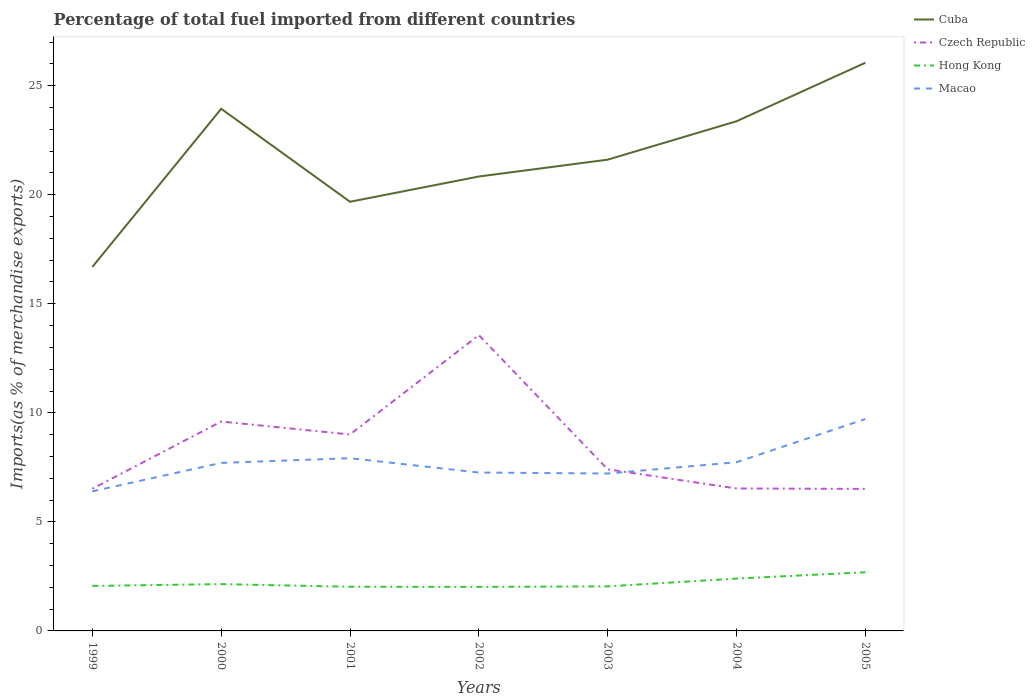Is the number of lines equal to the number of legend labels?
Your answer should be compact. Yes. Across all years, what is the maximum percentage of imports to different countries in Cuba?
Offer a very short reply. 16.69. In which year was the percentage of imports to different countries in Hong Kong maximum?
Your answer should be compact. 2002. What is the total percentage of imports to different countries in Hong Kong in the graph?
Ensure brevity in your answer.  -0.54. What is the difference between the highest and the second highest percentage of imports to different countries in Cuba?
Keep it short and to the point. 9.36. Are the values on the major ticks of Y-axis written in scientific E-notation?
Provide a succinct answer. No. What is the title of the graph?
Your response must be concise. Percentage of total fuel imported from different countries. What is the label or title of the Y-axis?
Provide a succinct answer. Imports(as % of merchandise exports). What is the Imports(as % of merchandise exports) in Cuba in 1999?
Provide a short and direct response. 16.69. What is the Imports(as % of merchandise exports) in Czech Republic in 1999?
Offer a very short reply. 6.52. What is the Imports(as % of merchandise exports) in Hong Kong in 1999?
Your answer should be compact. 2.06. What is the Imports(as % of merchandise exports) in Macao in 1999?
Provide a short and direct response. 6.4. What is the Imports(as % of merchandise exports) in Cuba in 2000?
Provide a short and direct response. 23.94. What is the Imports(as % of merchandise exports) of Czech Republic in 2000?
Provide a short and direct response. 9.6. What is the Imports(as % of merchandise exports) of Hong Kong in 2000?
Keep it short and to the point. 2.15. What is the Imports(as % of merchandise exports) of Macao in 2000?
Ensure brevity in your answer.  7.7. What is the Imports(as % of merchandise exports) of Cuba in 2001?
Offer a very short reply. 19.68. What is the Imports(as % of merchandise exports) in Czech Republic in 2001?
Offer a very short reply. 9.01. What is the Imports(as % of merchandise exports) in Hong Kong in 2001?
Offer a terse response. 2.03. What is the Imports(as % of merchandise exports) in Macao in 2001?
Your response must be concise. 7.92. What is the Imports(as % of merchandise exports) in Cuba in 2002?
Your answer should be compact. 20.84. What is the Imports(as % of merchandise exports) of Czech Republic in 2002?
Keep it short and to the point. 13.56. What is the Imports(as % of merchandise exports) of Hong Kong in 2002?
Give a very brief answer. 2.02. What is the Imports(as % of merchandise exports) in Macao in 2002?
Keep it short and to the point. 7.26. What is the Imports(as % of merchandise exports) in Cuba in 2003?
Provide a short and direct response. 21.61. What is the Imports(as % of merchandise exports) of Czech Republic in 2003?
Provide a succinct answer. 7.41. What is the Imports(as % of merchandise exports) in Hong Kong in 2003?
Your answer should be very brief. 2.04. What is the Imports(as % of merchandise exports) in Macao in 2003?
Your answer should be very brief. 7.22. What is the Imports(as % of merchandise exports) of Cuba in 2004?
Your answer should be very brief. 23.37. What is the Imports(as % of merchandise exports) of Czech Republic in 2004?
Ensure brevity in your answer.  6.53. What is the Imports(as % of merchandise exports) of Hong Kong in 2004?
Offer a very short reply. 2.4. What is the Imports(as % of merchandise exports) of Macao in 2004?
Ensure brevity in your answer.  7.74. What is the Imports(as % of merchandise exports) of Cuba in 2005?
Provide a short and direct response. 26.05. What is the Imports(as % of merchandise exports) of Czech Republic in 2005?
Provide a succinct answer. 6.51. What is the Imports(as % of merchandise exports) of Hong Kong in 2005?
Provide a short and direct response. 2.69. What is the Imports(as % of merchandise exports) in Macao in 2005?
Your response must be concise. 9.72. Across all years, what is the maximum Imports(as % of merchandise exports) of Cuba?
Your response must be concise. 26.05. Across all years, what is the maximum Imports(as % of merchandise exports) of Czech Republic?
Offer a very short reply. 13.56. Across all years, what is the maximum Imports(as % of merchandise exports) in Hong Kong?
Keep it short and to the point. 2.69. Across all years, what is the maximum Imports(as % of merchandise exports) in Macao?
Your response must be concise. 9.72. Across all years, what is the minimum Imports(as % of merchandise exports) in Cuba?
Your answer should be very brief. 16.69. Across all years, what is the minimum Imports(as % of merchandise exports) of Czech Republic?
Offer a terse response. 6.51. Across all years, what is the minimum Imports(as % of merchandise exports) of Hong Kong?
Offer a terse response. 2.02. Across all years, what is the minimum Imports(as % of merchandise exports) in Macao?
Ensure brevity in your answer.  6.4. What is the total Imports(as % of merchandise exports) of Cuba in the graph?
Ensure brevity in your answer.  152.17. What is the total Imports(as % of merchandise exports) of Czech Republic in the graph?
Your response must be concise. 59.14. What is the total Imports(as % of merchandise exports) in Hong Kong in the graph?
Your answer should be compact. 15.39. What is the total Imports(as % of merchandise exports) in Macao in the graph?
Your response must be concise. 53.96. What is the difference between the Imports(as % of merchandise exports) in Cuba in 1999 and that in 2000?
Your response must be concise. -7.25. What is the difference between the Imports(as % of merchandise exports) of Czech Republic in 1999 and that in 2000?
Ensure brevity in your answer.  -3.08. What is the difference between the Imports(as % of merchandise exports) of Hong Kong in 1999 and that in 2000?
Ensure brevity in your answer.  -0.08. What is the difference between the Imports(as % of merchandise exports) of Macao in 1999 and that in 2000?
Offer a terse response. -1.3. What is the difference between the Imports(as % of merchandise exports) in Cuba in 1999 and that in 2001?
Keep it short and to the point. -2.99. What is the difference between the Imports(as % of merchandise exports) in Czech Republic in 1999 and that in 2001?
Offer a very short reply. -2.49. What is the difference between the Imports(as % of merchandise exports) of Hong Kong in 1999 and that in 2001?
Offer a very short reply. 0.04. What is the difference between the Imports(as % of merchandise exports) in Macao in 1999 and that in 2001?
Make the answer very short. -1.52. What is the difference between the Imports(as % of merchandise exports) in Cuba in 1999 and that in 2002?
Give a very brief answer. -4.15. What is the difference between the Imports(as % of merchandise exports) in Czech Republic in 1999 and that in 2002?
Provide a short and direct response. -7.04. What is the difference between the Imports(as % of merchandise exports) of Hong Kong in 1999 and that in 2002?
Keep it short and to the point. 0.05. What is the difference between the Imports(as % of merchandise exports) in Macao in 1999 and that in 2002?
Offer a terse response. -0.86. What is the difference between the Imports(as % of merchandise exports) of Cuba in 1999 and that in 2003?
Offer a terse response. -4.92. What is the difference between the Imports(as % of merchandise exports) of Czech Republic in 1999 and that in 2003?
Keep it short and to the point. -0.89. What is the difference between the Imports(as % of merchandise exports) of Hong Kong in 1999 and that in 2003?
Offer a terse response. 0.02. What is the difference between the Imports(as % of merchandise exports) in Macao in 1999 and that in 2003?
Give a very brief answer. -0.82. What is the difference between the Imports(as % of merchandise exports) in Cuba in 1999 and that in 2004?
Ensure brevity in your answer.  -6.68. What is the difference between the Imports(as % of merchandise exports) in Czech Republic in 1999 and that in 2004?
Make the answer very short. -0.01. What is the difference between the Imports(as % of merchandise exports) of Hong Kong in 1999 and that in 2004?
Your response must be concise. -0.34. What is the difference between the Imports(as % of merchandise exports) of Macao in 1999 and that in 2004?
Offer a very short reply. -1.33. What is the difference between the Imports(as % of merchandise exports) in Cuba in 1999 and that in 2005?
Your answer should be very brief. -9.36. What is the difference between the Imports(as % of merchandise exports) in Czech Republic in 1999 and that in 2005?
Give a very brief answer. 0.01. What is the difference between the Imports(as % of merchandise exports) of Hong Kong in 1999 and that in 2005?
Make the answer very short. -0.63. What is the difference between the Imports(as % of merchandise exports) in Macao in 1999 and that in 2005?
Your response must be concise. -3.31. What is the difference between the Imports(as % of merchandise exports) of Cuba in 2000 and that in 2001?
Make the answer very short. 4.26. What is the difference between the Imports(as % of merchandise exports) in Czech Republic in 2000 and that in 2001?
Ensure brevity in your answer.  0.59. What is the difference between the Imports(as % of merchandise exports) of Hong Kong in 2000 and that in 2001?
Keep it short and to the point. 0.12. What is the difference between the Imports(as % of merchandise exports) of Macao in 2000 and that in 2001?
Your answer should be compact. -0.22. What is the difference between the Imports(as % of merchandise exports) in Cuba in 2000 and that in 2002?
Offer a very short reply. 3.11. What is the difference between the Imports(as % of merchandise exports) in Czech Republic in 2000 and that in 2002?
Offer a very short reply. -3.96. What is the difference between the Imports(as % of merchandise exports) of Hong Kong in 2000 and that in 2002?
Keep it short and to the point. 0.13. What is the difference between the Imports(as % of merchandise exports) in Macao in 2000 and that in 2002?
Give a very brief answer. 0.44. What is the difference between the Imports(as % of merchandise exports) of Cuba in 2000 and that in 2003?
Your answer should be very brief. 2.33. What is the difference between the Imports(as % of merchandise exports) of Czech Republic in 2000 and that in 2003?
Provide a succinct answer. 2.19. What is the difference between the Imports(as % of merchandise exports) of Hong Kong in 2000 and that in 2003?
Ensure brevity in your answer.  0.1. What is the difference between the Imports(as % of merchandise exports) of Macao in 2000 and that in 2003?
Your answer should be compact. 0.49. What is the difference between the Imports(as % of merchandise exports) in Cuba in 2000 and that in 2004?
Offer a terse response. 0.57. What is the difference between the Imports(as % of merchandise exports) in Czech Republic in 2000 and that in 2004?
Give a very brief answer. 3.07. What is the difference between the Imports(as % of merchandise exports) of Hong Kong in 2000 and that in 2004?
Keep it short and to the point. -0.25. What is the difference between the Imports(as % of merchandise exports) in Macao in 2000 and that in 2004?
Offer a terse response. -0.03. What is the difference between the Imports(as % of merchandise exports) of Cuba in 2000 and that in 2005?
Ensure brevity in your answer.  -2.11. What is the difference between the Imports(as % of merchandise exports) of Czech Republic in 2000 and that in 2005?
Offer a terse response. 3.09. What is the difference between the Imports(as % of merchandise exports) in Hong Kong in 2000 and that in 2005?
Offer a terse response. -0.54. What is the difference between the Imports(as % of merchandise exports) in Macao in 2000 and that in 2005?
Offer a very short reply. -2.01. What is the difference between the Imports(as % of merchandise exports) in Cuba in 2001 and that in 2002?
Your answer should be very brief. -1.16. What is the difference between the Imports(as % of merchandise exports) in Czech Republic in 2001 and that in 2002?
Keep it short and to the point. -4.56. What is the difference between the Imports(as % of merchandise exports) in Hong Kong in 2001 and that in 2002?
Provide a succinct answer. 0.01. What is the difference between the Imports(as % of merchandise exports) of Macao in 2001 and that in 2002?
Provide a succinct answer. 0.66. What is the difference between the Imports(as % of merchandise exports) of Cuba in 2001 and that in 2003?
Your answer should be very brief. -1.93. What is the difference between the Imports(as % of merchandise exports) of Czech Republic in 2001 and that in 2003?
Give a very brief answer. 1.6. What is the difference between the Imports(as % of merchandise exports) of Hong Kong in 2001 and that in 2003?
Your response must be concise. -0.02. What is the difference between the Imports(as % of merchandise exports) in Macao in 2001 and that in 2003?
Your answer should be compact. 0.7. What is the difference between the Imports(as % of merchandise exports) in Cuba in 2001 and that in 2004?
Your answer should be compact. -3.69. What is the difference between the Imports(as % of merchandise exports) in Czech Republic in 2001 and that in 2004?
Offer a terse response. 2.48. What is the difference between the Imports(as % of merchandise exports) of Hong Kong in 2001 and that in 2004?
Provide a succinct answer. -0.37. What is the difference between the Imports(as % of merchandise exports) of Macao in 2001 and that in 2004?
Your response must be concise. 0.18. What is the difference between the Imports(as % of merchandise exports) in Cuba in 2001 and that in 2005?
Keep it short and to the point. -6.37. What is the difference between the Imports(as % of merchandise exports) in Czech Republic in 2001 and that in 2005?
Provide a short and direct response. 2.5. What is the difference between the Imports(as % of merchandise exports) of Hong Kong in 2001 and that in 2005?
Provide a short and direct response. -0.67. What is the difference between the Imports(as % of merchandise exports) of Macao in 2001 and that in 2005?
Keep it short and to the point. -1.79. What is the difference between the Imports(as % of merchandise exports) of Cuba in 2002 and that in 2003?
Keep it short and to the point. -0.77. What is the difference between the Imports(as % of merchandise exports) of Czech Republic in 2002 and that in 2003?
Keep it short and to the point. 6.15. What is the difference between the Imports(as % of merchandise exports) of Hong Kong in 2002 and that in 2003?
Ensure brevity in your answer.  -0.03. What is the difference between the Imports(as % of merchandise exports) of Macao in 2002 and that in 2003?
Your response must be concise. 0.05. What is the difference between the Imports(as % of merchandise exports) of Cuba in 2002 and that in 2004?
Keep it short and to the point. -2.53. What is the difference between the Imports(as % of merchandise exports) of Czech Republic in 2002 and that in 2004?
Keep it short and to the point. 7.03. What is the difference between the Imports(as % of merchandise exports) in Hong Kong in 2002 and that in 2004?
Your answer should be very brief. -0.38. What is the difference between the Imports(as % of merchandise exports) in Macao in 2002 and that in 2004?
Offer a very short reply. -0.47. What is the difference between the Imports(as % of merchandise exports) in Cuba in 2002 and that in 2005?
Your answer should be very brief. -5.21. What is the difference between the Imports(as % of merchandise exports) in Czech Republic in 2002 and that in 2005?
Offer a terse response. 7.05. What is the difference between the Imports(as % of merchandise exports) in Hong Kong in 2002 and that in 2005?
Make the answer very short. -0.67. What is the difference between the Imports(as % of merchandise exports) in Macao in 2002 and that in 2005?
Your answer should be compact. -2.45. What is the difference between the Imports(as % of merchandise exports) of Cuba in 2003 and that in 2004?
Your response must be concise. -1.76. What is the difference between the Imports(as % of merchandise exports) in Czech Republic in 2003 and that in 2004?
Your response must be concise. 0.88. What is the difference between the Imports(as % of merchandise exports) in Hong Kong in 2003 and that in 2004?
Provide a short and direct response. -0.36. What is the difference between the Imports(as % of merchandise exports) of Macao in 2003 and that in 2004?
Your answer should be compact. -0.52. What is the difference between the Imports(as % of merchandise exports) in Cuba in 2003 and that in 2005?
Give a very brief answer. -4.44. What is the difference between the Imports(as % of merchandise exports) of Czech Republic in 2003 and that in 2005?
Provide a short and direct response. 0.9. What is the difference between the Imports(as % of merchandise exports) of Hong Kong in 2003 and that in 2005?
Your answer should be compact. -0.65. What is the difference between the Imports(as % of merchandise exports) in Macao in 2003 and that in 2005?
Your response must be concise. -2.5. What is the difference between the Imports(as % of merchandise exports) in Cuba in 2004 and that in 2005?
Ensure brevity in your answer.  -2.68. What is the difference between the Imports(as % of merchandise exports) in Czech Republic in 2004 and that in 2005?
Make the answer very short. 0.02. What is the difference between the Imports(as % of merchandise exports) in Hong Kong in 2004 and that in 2005?
Offer a very short reply. -0.29. What is the difference between the Imports(as % of merchandise exports) of Macao in 2004 and that in 2005?
Provide a short and direct response. -1.98. What is the difference between the Imports(as % of merchandise exports) of Cuba in 1999 and the Imports(as % of merchandise exports) of Czech Republic in 2000?
Your answer should be very brief. 7.09. What is the difference between the Imports(as % of merchandise exports) of Cuba in 1999 and the Imports(as % of merchandise exports) of Hong Kong in 2000?
Your answer should be compact. 14.54. What is the difference between the Imports(as % of merchandise exports) of Cuba in 1999 and the Imports(as % of merchandise exports) of Macao in 2000?
Ensure brevity in your answer.  8.99. What is the difference between the Imports(as % of merchandise exports) in Czech Republic in 1999 and the Imports(as % of merchandise exports) in Hong Kong in 2000?
Provide a short and direct response. 4.37. What is the difference between the Imports(as % of merchandise exports) of Czech Republic in 1999 and the Imports(as % of merchandise exports) of Macao in 2000?
Offer a terse response. -1.18. What is the difference between the Imports(as % of merchandise exports) in Hong Kong in 1999 and the Imports(as % of merchandise exports) in Macao in 2000?
Keep it short and to the point. -5.64. What is the difference between the Imports(as % of merchandise exports) of Cuba in 1999 and the Imports(as % of merchandise exports) of Czech Republic in 2001?
Provide a succinct answer. 7.68. What is the difference between the Imports(as % of merchandise exports) of Cuba in 1999 and the Imports(as % of merchandise exports) of Hong Kong in 2001?
Ensure brevity in your answer.  14.66. What is the difference between the Imports(as % of merchandise exports) of Cuba in 1999 and the Imports(as % of merchandise exports) of Macao in 2001?
Make the answer very short. 8.77. What is the difference between the Imports(as % of merchandise exports) in Czech Republic in 1999 and the Imports(as % of merchandise exports) in Hong Kong in 2001?
Keep it short and to the point. 4.49. What is the difference between the Imports(as % of merchandise exports) in Czech Republic in 1999 and the Imports(as % of merchandise exports) in Macao in 2001?
Offer a very short reply. -1.4. What is the difference between the Imports(as % of merchandise exports) in Hong Kong in 1999 and the Imports(as % of merchandise exports) in Macao in 2001?
Keep it short and to the point. -5.86. What is the difference between the Imports(as % of merchandise exports) in Cuba in 1999 and the Imports(as % of merchandise exports) in Czech Republic in 2002?
Offer a terse response. 3.13. What is the difference between the Imports(as % of merchandise exports) of Cuba in 1999 and the Imports(as % of merchandise exports) of Hong Kong in 2002?
Make the answer very short. 14.67. What is the difference between the Imports(as % of merchandise exports) of Cuba in 1999 and the Imports(as % of merchandise exports) of Macao in 2002?
Provide a succinct answer. 9.43. What is the difference between the Imports(as % of merchandise exports) of Czech Republic in 1999 and the Imports(as % of merchandise exports) of Hong Kong in 2002?
Keep it short and to the point. 4.5. What is the difference between the Imports(as % of merchandise exports) in Czech Republic in 1999 and the Imports(as % of merchandise exports) in Macao in 2002?
Your answer should be compact. -0.74. What is the difference between the Imports(as % of merchandise exports) of Hong Kong in 1999 and the Imports(as % of merchandise exports) of Macao in 2002?
Keep it short and to the point. -5.2. What is the difference between the Imports(as % of merchandise exports) of Cuba in 1999 and the Imports(as % of merchandise exports) of Czech Republic in 2003?
Your answer should be compact. 9.28. What is the difference between the Imports(as % of merchandise exports) of Cuba in 1999 and the Imports(as % of merchandise exports) of Hong Kong in 2003?
Make the answer very short. 14.65. What is the difference between the Imports(as % of merchandise exports) in Cuba in 1999 and the Imports(as % of merchandise exports) in Macao in 2003?
Keep it short and to the point. 9.47. What is the difference between the Imports(as % of merchandise exports) of Czech Republic in 1999 and the Imports(as % of merchandise exports) of Hong Kong in 2003?
Offer a terse response. 4.48. What is the difference between the Imports(as % of merchandise exports) in Czech Republic in 1999 and the Imports(as % of merchandise exports) in Macao in 2003?
Keep it short and to the point. -0.7. What is the difference between the Imports(as % of merchandise exports) of Hong Kong in 1999 and the Imports(as % of merchandise exports) of Macao in 2003?
Provide a short and direct response. -5.15. What is the difference between the Imports(as % of merchandise exports) of Cuba in 1999 and the Imports(as % of merchandise exports) of Czech Republic in 2004?
Your response must be concise. 10.16. What is the difference between the Imports(as % of merchandise exports) in Cuba in 1999 and the Imports(as % of merchandise exports) in Hong Kong in 2004?
Your response must be concise. 14.29. What is the difference between the Imports(as % of merchandise exports) of Cuba in 1999 and the Imports(as % of merchandise exports) of Macao in 2004?
Your answer should be compact. 8.95. What is the difference between the Imports(as % of merchandise exports) in Czech Republic in 1999 and the Imports(as % of merchandise exports) in Hong Kong in 2004?
Your response must be concise. 4.12. What is the difference between the Imports(as % of merchandise exports) of Czech Republic in 1999 and the Imports(as % of merchandise exports) of Macao in 2004?
Ensure brevity in your answer.  -1.22. What is the difference between the Imports(as % of merchandise exports) of Hong Kong in 1999 and the Imports(as % of merchandise exports) of Macao in 2004?
Make the answer very short. -5.67. What is the difference between the Imports(as % of merchandise exports) of Cuba in 1999 and the Imports(as % of merchandise exports) of Czech Republic in 2005?
Offer a very short reply. 10.18. What is the difference between the Imports(as % of merchandise exports) in Cuba in 1999 and the Imports(as % of merchandise exports) in Hong Kong in 2005?
Offer a very short reply. 14. What is the difference between the Imports(as % of merchandise exports) in Cuba in 1999 and the Imports(as % of merchandise exports) in Macao in 2005?
Offer a very short reply. 6.97. What is the difference between the Imports(as % of merchandise exports) of Czech Republic in 1999 and the Imports(as % of merchandise exports) of Hong Kong in 2005?
Your answer should be very brief. 3.83. What is the difference between the Imports(as % of merchandise exports) of Czech Republic in 1999 and the Imports(as % of merchandise exports) of Macao in 2005?
Ensure brevity in your answer.  -3.2. What is the difference between the Imports(as % of merchandise exports) of Hong Kong in 1999 and the Imports(as % of merchandise exports) of Macao in 2005?
Provide a succinct answer. -7.65. What is the difference between the Imports(as % of merchandise exports) of Cuba in 2000 and the Imports(as % of merchandise exports) of Czech Republic in 2001?
Give a very brief answer. 14.94. What is the difference between the Imports(as % of merchandise exports) of Cuba in 2000 and the Imports(as % of merchandise exports) of Hong Kong in 2001?
Your answer should be compact. 21.92. What is the difference between the Imports(as % of merchandise exports) in Cuba in 2000 and the Imports(as % of merchandise exports) in Macao in 2001?
Provide a short and direct response. 16.02. What is the difference between the Imports(as % of merchandise exports) in Czech Republic in 2000 and the Imports(as % of merchandise exports) in Hong Kong in 2001?
Ensure brevity in your answer.  7.58. What is the difference between the Imports(as % of merchandise exports) in Czech Republic in 2000 and the Imports(as % of merchandise exports) in Macao in 2001?
Provide a succinct answer. 1.68. What is the difference between the Imports(as % of merchandise exports) in Hong Kong in 2000 and the Imports(as % of merchandise exports) in Macao in 2001?
Your answer should be compact. -5.77. What is the difference between the Imports(as % of merchandise exports) of Cuba in 2000 and the Imports(as % of merchandise exports) of Czech Republic in 2002?
Provide a short and direct response. 10.38. What is the difference between the Imports(as % of merchandise exports) of Cuba in 2000 and the Imports(as % of merchandise exports) of Hong Kong in 2002?
Offer a terse response. 21.92. What is the difference between the Imports(as % of merchandise exports) of Cuba in 2000 and the Imports(as % of merchandise exports) of Macao in 2002?
Keep it short and to the point. 16.68. What is the difference between the Imports(as % of merchandise exports) of Czech Republic in 2000 and the Imports(as % of merchandise exports) of Hong Kong in 2002?
Keep it short and to the point. 7.58. What is the difference between the Imports(as % of merchandise exports) of Czech Republic in 2000 and the Imports(as % of merchandise exports) of Macao in 2002?
Give a very brief answer. 2.34. What is the difference between the Imports(as % of merchandise exports) of Hong Kong in 2000 and the Imports(as % of merchandise exports) of Macao in 2002?
Give a very brief answer. -5.12. What is the difference between the Imports(as % of merchandise exports) in Cuba in 2000 and the Imports(as % of merchandise exports) in Czech Republic in 2003?
Your response must be concise. 16.53. What is the difference between the Imports(as % of merchandise exports) in Cuba in 2000 and the Imports(as % of merchandise exports) in Hong Kong in 2003?
Your answer should be very brief. 21.9. What is the difference between the Imports(as % of merchandise exports) in Cuba in 2000 and the Imports(as % of merchandise exports) in Macao in 2003?
Offer a terse response. 16.73. What is the difference between the Imports(as % of merchandise exports) in Czech Republic in 2000 and the Imports(as % of merchandise exports) in Hong Kong in 2003?
Give a very brief answer. 7.56. What is the difference between the Imports(as % of merchandise exports) of Czech Republic in 2000 and the Imports(as % of merchandise exports) of Macao in 2003?
Your answer should be compact. 2.38. What is the difference between the Imports(as % of merchandise exports) of Hong Kong in 2000 and the Imports(as % of merchandise exports) of Macao in 2003?
Your response must be concise. -5.07. What is the difference between the Imports(as % of merchandise exports) in Cuba in 2000 and the Imports(as % of merchandise exports) in Czech Republic in 2004?
Make the answer very short. 17.41. What is the difference between the Imports(as % of merchandise exports) in Cuba in 2000 and the Imports(as % of merchandise exports) in Hong Kong in 2004?
Offer a very short reply. 21.54. What is the difference between the Imports(as % of merchandise exports) in Cuba in 2000 and the Imports(as % of merchandise exports) in Macao in 2004?
Make the answer very short. 16.21. What is the difference between the Imports(as % of merchandise exports) in Czech Republic in 2000 and the Imports(as % of merchandise exports) in Hong Kong in 2004?
Ensure brevity in your answer.  7.2. What is the difference between the Imports(as % of merchandise exports) of Czech Republic in 2000 and the Imports(as % of merchandise exports) of Macao in 2004?
Offer a very short reply. 1.87. What is the difference between the Imports(as % of merchandise exports) of Hong Kong in 2000 and the Imports(as % of merchandise exports) of Macao in 2004?
Ensure brevity in your answer.  -5.59. What is the difference between the Imports(as % of merchandise exports) of Cuba in 2000 and the Imports(as % of merchandise exports) of Czech Republic in 2005?
Offer a terse response. 17.43. What is the difference between the Imports(as % of merchandise exports) in Cuba in 2000 and the Imports(as % of merchandise exports) in Hong Kong in 2005?
Offer a terse response. 21.25. What is the difference between the Imports(as % of merchandise exports) of Cuba in 2000 and the Imports(as % of merchandise exports) of Macao in 2005?
Offer a terse response. 14.23. What is the difference between the Imports(as % of merchandise exports) of Czech Republic in 2000 and the Imports(as % of merchandise exports) of Hong Kong in 2005?
Keep it short and to the point. 6.91. What is the difference between the Imports(as % of merchandise exports) of Czech Republic in 2000 and the Imports(as % of merchandise exports) of Macao in 2005?
Provide a succinct answer. -0.11. What is the difference between the Imports(as % of merchandise exports) of Hong Kong in 2000 and the Imports(as % of merchandise exports) of Macao in 2005?
Provide a short and direct response. -7.57. What is the difference between the Imports(as % of merchandise exports) in Cuba in 2001 and the Imports(as % of merchandise exports) in Czech Republic in 2002?
Make the answer very short. 6.12. What is the difference between the Imports(as % of merchandise exports) in Cuba in 2001 and the Imports(as % of merchandise exports) in Hong Kong in 2002?
Offer a terse response. 17.66. What is the difference between the Imports(as % of merchandise exports) of Cuba in 2001 and the Imports(as % of merchandise exports) of Macao in 2002?
Give a very brief answer. 12.41. What is the difference between the Imports(as % of merchandise exports) in Czech Republic in 2001 and the Imports(as % of merchandise exports) in Hong Kong in 2002?
Your response must be concise. 6.99. What is the difference between the Imports(as % of merchandise exports) in Czech Republic in 2001 and the Imports(as % of merchandise exports) in Macao in 2002?
Offer a terse response. 1.74. What is the difference between the Imports(as % of merchandise exports) in Hong Kong in 2001 and the Imports(as % of merchandise exports) in Macao in 2002?
Provide a short and direct response. -5.24. What is the difference between the Imports(as % of merchandise exports) in Cuba in 2001 and the Imports(as % of merchandise exports) in Czech Republic in 2003?
Your answer should be compact. 12.27. What is the difference between the Imports(as % of merchandise exports) of Cuba in 2001 and the Imports(as % of merchandise exports) of Hong Kong in 2003?
Your response must be concise. 17.63. What is the difference between the Imports(as % of merchandise exports) of Cuba in 2001 and the Imports(as % of merchandise exports) of Macao in 2003?
Offer a very short reply. 12.46. What is the difference between the Imports(as % of merchandise exports) in Czech Republic in 2001 and the Imports(as % of merchandise exports) in Hong Kong in 2003?
Your answer should be very brief. 6.96. What is the difference between the Imports(as % of merchandise exports) in Czech Republic in 2001 and the Imports(as % of merchandise exports) in Macao in 2003?
Keep it short and to the point. 1.79. What is the difference between the Imports(as % of merchandise exports) of Hong Kong in 2001 and the Imports(as % of merchandise exports) of Macao in 2003?
Offer a very short reply. -5.19. What is the difference between the Imports(as % of merchandise exports) in Cuba in 2001 and the Imports(as % of merchandise exports) in Czech Republic in 2004?
Your answer should be very brief. 13.15. What is the difference between the Imports(as % of merchandise exports) in Cuba in 2001 and the Imports(as % of merchandise exports) in Hong Kong in 2004?
Your answer should be compact. 17.28. What is the difference between the Imports(as % of merchandise exports) of Cuba in 2001 and the Imports(as % of merchandise exports) of Macao in 2004?
Make the answer very short. 11.94. What is the difference between the Imports(as % of merchandise exports) in Czech Republic in 2001 and the Imports(as % of merchandise exports) in Hong Kong in 2004?
Your answer should be compact. 6.61. What is the difference between the Imports(as % of merchandise exports) of Czech Republic in 2001 and the Imports(as % of merchandise exports) of Macao in 2004?
Provide a short and direct response. 1.27. What is the difference between the Imports(as % of merchandise exports) in Hong Kong in 2001 and the Imports(as % of merchandise exports) in Macao in 2004?
Your response must be concise. -5.71. What is the difference between the Imports(as % of merchandise exports) of Cuba in 2001 and the Imports(as % of merchandise exports) of Czech Republic in 2005?
Your response must be concise. 13.17. What is the difference between the Imports(as % of merchandise exports) in Cuba in 2001 and the Imports(as % of merchandise exports) in Hong Kong in 2005?
Make the answer very short. 16.99. What is the difference between the Imports(as % of merchandise exports) of Cuba in 2001 and the Imports(as % of merchandise exports) of Macao in 2005?
Keep it short and to the point. 9.96. What is the difference between the Imports(as % of merchandise exports) of Czech Republic in 2001 and the Imports(as % of merchandise exports) of Hong Kong in 2005?
Make the answer very short. 6.32. What is the difference between the Imports(as % of merchandise exports) of Czech Republic in 2001 and the Imports(as % of merchandise exports) of Macao in 2005?
Keep it short and to the point. -0.71. What is the difference between the Imports(as % of merchandise exports) of Hong Kong in 2001 and the Imports(as % of merchandise exports) of Macao in 2005?
Keep it short and to the point. -7.69. What is the difference between the Imports(as % of merchandise exports) of Cuba in 2002 and the Imports(as % of merchandise exports) of Czech Republic in 2003?
Ensure brevity in your answer.  13.43. What is the difference between the Imports(as % of merchandise exports) of Cuba in 2002 and the Imports(as % of merchandise exports) of Hong Kong in 2003?
Your answer should be very brief. 18.79. What is the difference between the Imports(as % of merchandise exports) in Cuba in 2002 and the Imports(as % of merchandise exports) in Macao in 2003?
Offer a very short reply. 13.62. What is the difference between the Imports(as % of merchandise exports) of Czech Republic in 2002 and the Imports(as % of merchandise exports) of Hong Kong in 2003?
Provide a succinct answer. 11.52. What is the difference between the Imports(as % of merchandise exports) in Czech Republic in 2002 and the Imports(as % of merchandise exports) in Macao in 2003?
Keep it short and to the point. 6.35. What is the difference between the Imports(as % of merchandise exports) in Hong Kong in 2002 and the Imports(as % of merchandise exports) in Macao in 2003?
Provide a short and direct response. -5.2. What is the difference between the Imports(as % of merchandise exports) in Cuba in 2002 and the Imports(as % of merchandise exports) in Czech Republic in 2004?
Offer a very short reply. 14.3. What is the difference between the Imports(as % of merchandise exports) of Cuba in 2002 and the Imports(as % of merchandise exports) of Hong Kong in 2004?
Your response must be concise. 18.44. What is the difference between the Imports(as % of merchandise exports) of Cuba in 2002 and the Imports(as % of merchandise exports) of Macao in 2004?
Give a very brief answer. 13.1. What is the difference between the Imports(as % of merchandise exports) in Czech Republic in 2002 and the Imports(as % of merchandise exports) in Hong Kong in 2004?
Provide a short and direct response. 11.16. What is the difference between the Imports(as % of merchandise exports) in Czech Republic in 2002 and the Imports(as % of merchandise exports) in Macao in 2004?
Give a very brief answer. 5.83. What is the difference between the Imports(as % of merchandise exports) of Hong Kong in 2002 and the Imports(as % of merchandise exports) of Macao in 2004?
Offer a very short reply. -5.72. What is the difference between the Imports(as % of merchandise exports) of Cuba in 2002 and the Imports(as % of merchandise exports) of Czech Republic in 2005?
Give a very brief answer. 14.32. What is the difference between the Imports(as % of merchandise exports) of Cuba in 2002 and the Imports(as % of merchandise exports) of Hong Kong in 2005?
Offer a very short reply. 18.15. What is the difference between the Imports(as % of merchandise exports) of Cuba in 2002 and the Imports(as % of merchandise exports) of Macao in 2005?
Keep it short and to the point. 11.12. What is the difference between the Imports(as % of merchandise exports) in Czech Republic in 2002 and the Imports(as % of merchandise exports) in Hong Kong in 2005?
Offer a terse response. 10.87. What is the difference between the Imports(as % of merchandise exports) of Czech Republic in 2002 and the Imports(as % of merchandise exports) of Macao in 2005?
Offer a terse response. 3.85. What is the difference between the Imports(as % of merchandise exports) in Hong Kong in 2002 and the Imports(as % of merchandise exports) in Macao in 2005?
Offer a terse response. -7.7. What is the difference between the Imports(as % of merchandise exports) in Cuba in 2003 and the Imports(as % of merchandise exports) in Czech Republic in 2004?
Provide a succinct answer. 15.08. What is the difference between the Imports(as % of merchandise exports) of Cuba in 2003 and the Imports(as % of merchandise exports) of Hong Kong in 2004?
Your answer should be very brief. 19.21. What is the difference between the Imports(as % of merchandise exports) in Cuba in 2003 and the Imports(as % of merchandise exports) in Macao in 2004?
Provide a succinct answer. 13.87. What is the difference between the Imports(as % of merchandise exports) in Czech Republic in 2003 and the Imports(as % of merchandise exports) in Hong Kong in 2004?
Make the answer very short. 5.01. What is the difference between the Imports(as % of merchandise exports) of Czech Republic in 2003 and the Imports(as % of merchandise exports) of Macao in 2004?
Your response must be concise. -0.33. What is the difference between the Imports(as % of merchandise exports) of Hong Kong in 2003 and the Imports(as % of merchandise exports) of Macao in 2004?
Your answer should be very brief. -5.69. What is the difference between the Imports(as % of merchandise exports) of Cuba in 2003 and the Imports(as % of merchandise exports) of Czech Republic in 2005?
Your answer should be compact. 15.1. What is the difference between the Imports(as % of merchandise exports) of Cuba in 2003 and the Imports(as % of merchandise exports) of Hong Kong in 2005?
Give a very brief answer. 18.92. What is the difference between the Imports(as % of merchandise exports) of Cuba in 2003 and the Imports(as % of merchandise exports) of Macao in 2005?
Offer a terse response. 11.89. What is the difference between the Imports(as % of merchandise exports) of Czech Republic in 2003 and the Imports(as % of merchandise exports) of Hong Kong in 2005?
Ensure brevity in your answer.  4.72. What is the difference between the Imports(as % of merchandise exports) in Czech Republic in 2003 and the Imports(as % of merchandise exports) in Macao in 2005?
Make the answer very short. -2.31. What is the difference between the Imports(as % of merchandise exports) of Hong Kong in 2003 and the Imports(as % of merchandise exports) of Macao in 2005?
Give a very brief answer. -7.67. What is the difference between the Imports(as % of merchandise exports) of Cuba in 2004 and the Imports(as % of merchandise exports) of Czech Republic in 2005?
Your answer should be compact. 16.86. What is the difference between the Imports(as % of merchandise exports) in Cuba in 2004 and the Imports(as % of merchandise exports) in Hong Kong in 2005?
Your answer should be compact. 20.68. What is the difference between the Imports(as % of merchandise exports) of Cuba in 2004 and the Imports(as % of merchandise exports) of Macao in 2005?
Provide a short and direct response. 13.65. What is the difference between the Imports(as % of merchandise exports) of Czech Republic in 2004 and the Imports(as % of merchandise exports) of Hong Kong in 2005?
Provide a succinct answer. 3.84. What is the difference between the Imports(as % of merchandise exports) in Czech Republic in 2004 and the Imports(as % of merchandise exports) in Macao in 2005?
Provide a succinct answer. -3.18. What is the difference between the Imports(as % of merchandise exports) of Hong Kong in 2004 and the Imports(as % of merchandise exports) of Macao in 2005?
Your response must be concise. -7.32. What is the average Imports(as % of merchandise exports) in Cuba per year?
Make the answer very short. 21.74. What is the average Imports(as % of merchandise exports) of Czech Republic per year?
Provide a succinct answer. 8.45. What is the average Imports(as % of merchandise exports) of Hong Kong per year?
Provide a short and direct response. 2.2. What is the average Imports(as % of merchandise exports) of Macao per year?
Keep it short and to the point. 7.71. In the year 1999, what is the difference between the Imports(as % of merchandise exports) in Cuba and Imports(as % of merchandise exports) in Czech Republic?
Provide a succinct answer. 10.17. In the year 1999, what is the difference between the Imports(as % of merchandise exports) of Cuba and Imports(as % of merchandise exports) of Hong Kong?
Make the answer very short. 14.63. In the year 1999, what is the difference between the Imports(as % of merchandise exports) in Cuba and Imports(as % of merchandise exports) in Macao?
Give a very brief answer. 10.29. In the year 1999, what is the difference between the Imports(as % of merchandise exports) of Czech Republic and Imports(as % of merchandise exports) of Hong Kong?
Your answer should be compact. 4.46. In the year 1999, what is the difference between the Imports(as % of merchandise exports) in Czech Republic and Imports(as % of merchandise exports) in Macao?
Your answer should be compact. 0.12. In the year 1999, what is the difference between the Imports(as % of merchandise exports) in Hong Kong and Imports(as % of merchandise exports) in Macao?
Give a very brief answer. -4.34. In the year 2000, what is the difference between the Imports(as % of merchandise exports) of Cuba and Imports(as % of merchandise exports) of Czech Republic?
Keep it short and to the point. 14.34. In the year 2000, what is the difference between the Imports(as % of merchandise exports) of Cuba and Imports(as % of merchandise exports) of Hong Kong?
Offer a very short reply. 21.8. In the year 2000, what is the difference between the Imports(as % of merchandise exports) in Cuba and Imports(as % of merchandise exports) in Macao?
Make the answer very short. 16.24. In the year 2000, what is the difference between the Imports(as % of merchandise exports) of Czech Republic and Imports(as % of merchandise exports) of Hong Kong?
Provide a short and direct response. 7.46. In the year 2000, what is the difference between the Imports(as % of merchandise exports) of Czech Republic and Imports(as % of merchandise exports) of Macao?
Your response must be concise. 1.9. In the year 2000, what is the difference between the Imports(as % of merchandise exports) of Hong Kong and Imports(as % of merchandise exports) of Macao?
Give a very brief answer. -5.56. In the year 2001, what is the difference between the Imports(as % of merchandise exports) in Cuba and Imports(as % of merchandise exports) in Czech Republic?
Make the answer very short. 10.67. In the year 2001, what is the difference between the Imports(as % of merchandise exports) in Cuba and Imports(as % of merchandise exports) in Hong Kong?
Your answer should be compact. 17.65. In the year 2001, what is the difference between the Imports(as % of merchandise exports) in Cuba and Imports(as % of merchandise exports) in Macao?
Your response must be concise. 11.76. In the year 2001, what is the difference between the Imports(as % of merchandise exports) in Czech Republic and Imports(as % of merchandise exports) in Hong Kong?
Give a very brief answer. 6.98. In the year 2001, what is the difference between the Imports(as % of merchandise exports) in Czech Republic and Imports(as % of merchandise exports) in Macao?
Ensure brevity in your answer.  1.09. In the year 2001, what is the difference between the Imports(as % of merchandise exports) in Hong Kong and Imports(as % of merchandise exports) in Macao?
Your answer should be compact. -5.9. In the year 2002, what is the difference between the Imports(as % of merchandise exports) in Cuba and Imports(as % of merchandise exports) in Czech Republic?
Give a very brief answer. 7.27. In the year 2002, what is the difference between the Imports(as % of merchandise exports) in Cuba and Imports(as % of merchandise exports) in Hong Kong?
Make the answer very short. 18.82. In the year 2002, what is the difference between the Imports(as % of merchandise exports) of Cuba and Imports(as % of merchandise exports) of Macao?
Your response must be concise. 13.57. In the year 2002, what is the difference between the Imports(as % of merchandise exports) of Czech Republic and Imports(as % of merchandise exports) of Hong Kong?
Ensure brevity in your answer.  11.54. In the year 2002, what is the difference between the Imports(as % of merchandise exports) in Czech Republic and Imports(as % of merchandise exports) in Macao?
Offer a terse response. 6.3. In the year 2002, what is the difference between the Imports(as % of merchandise exports) of Hong Kong and Imports(as % of merchandise exports) of Macao?
Your response must be concise. -5.25. In the year 2003, what is the difference between the Imports(as % of merchandise exports) of Cuba and Imports(as % of merchandise exports) of Czech Republic?
Provide a succinct answer. 14.2. In the year 2003, what is the difference between the Imports(as % of merchandise exports) in Cuba and Imports(as % of merchandise exports) in Hong Kong?
Your response must be concise. 19.57. In the year 2003, what is the difference between the Imports(as % of merchandise exports) of Cuba and Imports(as % of merchandise exports) of Macao?
Offer a terse response. 14.39. In the year 2003, what is the difference between the Imports(as % of merchandise exports) in Czech Republic and Imports(as % of merchandise exports) in Hong Kong?
Keep it short and to the point. 5.37. In the year 2003, what is the difference between the Imports(as % of merchandise exports) of Czech Republic and Imports(as % of merchandise exports) of Macao?
Keep it short and to the point. 0.19. In the year 2003, what is the difference between the Imports(as % of merchandise exports) of Hong Kong and Imports(as % of merchandise exports) of Macao?
Offer a terse response. -5.17. In the year 2004, what is the difference between the Imports(as % of merchandise exports) of Cuba and Imports(as % of merchandise exports) of Czech Republic?
Provide a succinct answer. 16.84. In the year 2004, what is the difference between the Imports(as % of merchandise exports) in Cuba and Imports(as % of merchandise exports) in Hong Kong?
Make the answer very short. 20.97. In the year 2004, what is the difference between the Imports(as % of merchandise exports) of Cuba and Imports(as % of merchandise exports) of Macao?
Ensure brevity in your answer.  15.63. In the year 2004, what is the difference between the Imports(as % of merchandise exports) of Czech Republic and Imports(as % of merchandise exports) of Hong Kong?
Your response must be concise. 4.13. In the year 2004, what is the difference between the Imports(as % of merchandise exports) in Czech Republic and Imports(as % of merchandise exports) in Macao?
Your answer should be very brief. -1.2. In the year 2004, what is the difference between the Imports(as % of merchandise exports) of Hong Kong and Imports(as % of merchandise exports) of Macao?
Your answer should be compact. -5.34. In the year 2005, what is the difference between the Imports(as % of merchandise exports) in Cuba and Imports(as % of merchandise exports) in Czech Republic?
Make the answer very short. 19.54. In the year 2005, what is the difference between the Imports(as % of merchandise exports) of Cuba and Imports(as % of merchandise exports) of Hong Kong?
Offer a very short reply. 23.36. In the year 2005, what is the difference between the Imports(as % of merchandise exports) in Cuba and Imports(as % of merchandise exports) in Macao?
Provide a succinct answer. 16.34. In the year 2005, what is the difference between the Imports(as % of merchandise exports) in Czech Republic and Imports(as % of merchandise exports) in Hong Kong?
Your answer should be compact. 3.82. In the year 2005, what is the difference between the Imports(as % of merchandise exports) of Czech Republic and Imports(as % of merchandise exports) of Macao?
Offer a terse response. -3.2. In the year 2005, what is the difference between the Imports(as % of merchandise exports) in Hong Kong and Imports(as % of merchandise exports) in Macao?
Offer a terse response. -7.03. What is the ratio of the Imports(as % of merchandise exports) of Cuba in 1999 to that in 2000?
Give a very brief answer. 0.7. What is the ratio of the Imports(as % of merchandise exports) of Czech Republic in 1999 to that in 2000?
Ensure brevity in your answer.  0.68. What is the ratio of the Imports(as % of merchandise exports) in Hong Kong in 1999 to that in 2000?
Make the answer very short. 0.96. What is the ratio of the Imports(as % of merchandise exports) in Macao in 1999 to that in 2000?
Keep it short and to the point. 0.83. What is the ratio of the Imports(as % of merchandise exports) of Cuba in 1999 to that in 2001?
Provide a succinct answer. 0.85. What is the ratio of the Imports(as % of merchandise exports) in Czech Republic in 1999 to that in 2001?
Your response must be concise. 0.72. What is the ratio of the Imports(as % of merchandise exports) in Hong Kong in 1999 to that in 2001?
Offer a very short reply. 1.02. What is the ratio of the Imports(as % of merchandise exports) of Macao in 1999 to that in 2001?
Your answer should be compact. 0.81. What is the ratio of the Imports(as % of merchandise exports) in Cuba in 1999 to that in 2002?
Provide a succinct answer. 0.8. What is the ratio of the Imports(as % of merchandise exports) in Czech Republic in 1999 to that in 2002?
Offer a terse response. 0.48. What is the ratio of the Imports(as % of merchandise exports) of Hong Kong in 1999 to that in 2002?
Provide a succinct answer. 1.02. What is the ratio of the Imports(as % of merchandise exports) of Macao in 1999 to that in 2002?
Your answer should be compact. 0.88. What is the ratio of the Imports(as % of merchandise exports) of Cuba in 1999 to that in 2003?
Ensure brevity in your answer.  0.77. What is the ratio of the Imports(as % of merchandise exports) in Czech Republic in 1999 to that in 2003?
Your answer should be very brief. 0.88. What is the ratio of the Imports(as % of merchandise exports) of Hong Kong in 1999 to that in 2003?
Your response must be concise. 1.01. What is the ratio of the Imports(as % of merchandise exports) of Macao in 1999 to that in 2003?
Provide a succinct answer. 0.89. What is the ratio of the Imports(as % of merchandise exports) of Cuba in 1999 to that in 2004?
Your response must be concise. 0.71. What is the ratio of the Imports(as % of merchandise exports) in Czech Republic in 1999 to that in 2004?
Give a very brief answer. 1. What is the ratio of the Imports(as % of merchandise exports) in Hong Kong in 1999 to that in 2004?
Your answer should be compact. 0.86. What is the ratio of the Imports(as % of merchandise exports) of Macao in 1999 to that in 2004?
Offer a very short reply. 0.83. What is the ratio of the Imports(as % of merchandise exports) of Cuba in 1999 to that in 2005?
Provide a succinct answer. 0.64. What is the ratio of the Imports(as % of merchandise exports) in Czech Republic in 1999 to that in 2005?
Ensure brevity in your answer.  1. What is the ratio of the Imports(as % of merchandise exports) of Hong Kong in 1999 to that in 2005?
Keep it short and to the point. 0.77. What is the ratio of the Imports(as % of merchandise exports) of Macao in 1999 to that in 2005?
Your response must be concise. 0.66. What is the ratio of the Imports(as % of merchandise exports) of Cuba in 2000 to that in 2001?
Make the answer very short. 1.22. What is the ratio of the Imports(as % of merchandise exports) of Czech Republic in 2000 to that in 2001?
Keep it short and to the point. 1.07. What is the ratio of the Imports(as % of merchandise exports) of Hong Kong in 2000 to that in 2001?
Your response must be concise. 1.06. What is the ratio of the Imports(as % of merchandise exports) in Macao in 2000 to that in 2001?
Your response must be concise. 0.97. What is the ratio of the Imports(as % of merchandise exports) in Cuba in 2000 to that in 2002?
Give a very brief answer. 1.15. What is the ratio of the Imports(as % of merchandise exports) of Czech Republic in 2000 to that in 2002?
Your answer should be compact. 0.71. What is the ratio of the Imports(as % of merchandise exports) of Hong Kong in 2000 to that in 2002?
Provide a succinct answer. 1.06. What is the ratio of the Imports(as % of merchandise exports) in Macao in 2000 to that in 2002?
Offer a very short reply. 1.06. What is the ratio of the Imports(as % of merchandise exports) in Cuba in 2000 to that in 2003?
Make the answer very short. 1.11. What is the ratio of the Imports(as % of merchandise exports) of Czech Republic in 2000 to that in 2003?
Offer a very short reply. 1.3. What is the ratio of the Imports(as % of merchandise exports) of Hong Kong in 2000 to that in 2003?
Give a very brief answer. 1.05. What is the ratio of the Imports(as % of merchandise exports) of Macao in 2000 to that in 2003?
Make the answer very short. 1.07. What is the ratio of the Imports(as % of merchandise exports) in Cuba in 2000 to that in 2004?
Your answer should be very brief. 1.02. What is the ratio of the Imports(as % of merchandise exports) of Czech Republic in 2000 to that in 2004?
Give a very brief answer. 1.47. What is the ratio of the Imports(as % of merchandise exports) of Hong Kong in 2000 to that in 2004?
Provide a succinct answer. 0.89. What is the ratio of the Imports(as % of merchandise exports) of Macao in 2000 to that in 2004?
Give a very brief answer. 1. What is the ratio of the Imports(as % of merchandise exports) in Cuba in 2000 to that in 2005?
Keep it short and to the point. 0.92. What is the ratio of the Imports(as % of merchandise exports) in Czech Republic in 2000 to that in 2005?
Offer a very short reply. 1.47. What is the ratio of the Imports(as % of merchandise exports) of Hong Kong in 2000 to that in 2005?
Offer a terse response. 0.8. What is the ratio of the Imports(as % of merchandise exports) in Macao in 2000 to that in 2005?
Make the answer very short. 0.79. What is the ratio of the Imports(as % of merchandise exports) in Cuba in 2001 to that in 2002?
Provide a succinct answer. 0.94. What is the ratio of the Imports(as % of merchandise exports) of Czech Republic in 2001 to that in 2002?
Give a very brief answer. 0.66. What is the ratio of the Imports(as % of merchandise exports) in Macao in 2001 to that in 2002?
Provide a succinct answer. 1.09. What is the ratio of the Imports(as % of merchandise exports) in Cuba in 2001 to that in 2003?
Keep it short and to the point. 0.91. What is the ratio of the Imports(as % of merchandise exports) of Czech Republic in 2001 to that in 2003?
Keep it short and to the point. 1.22. What is the ratio of the Imports(as % of merchandise exports) of Macao in 2001 to that in 2003?
Your answer should be very brief. 1.1. What is the ratio of the Imports(as % of merchandise exports) in Cuba in 2001 to that in 2004?
Give a very brief answer. 0.84. What is the ratio of the Imports(as % of merchandise exports) of Czech Republic in 2001 to that in 2004?
Offer a terse response. 1.38. What is the ratio of the Imports(as % of merchandise exports) of Hong Kong in 2001 to that in 2004?
Provide a succinct answer. 0.84. What is the ratio of the Imports(as % of merchandise exports) of Macao in 2001 to that in 2004?
Make the answer very short. 1.02. What is the ratio of the Imports(as % of merchandise exports) of Cuba in 2001 to that in 2005?
Provide a succinct answer. 0.76. What is the ratio of the Imports(as % of merchandise exports) of Czech Republic in 2001 to that in 2005?
Provide a short and direct response. 1.38. What is the ratio of the Imports(as % of merchandise exports) of Hong Kong in 2001 to that in 2005?
Offer a very short reply. 0.75. What is the ratio of the Imports(as % of merchandise exports) of Macao in 2001 to that in 2005?
Your answer should be very brief. 0.82. What is the ratio of the Imports(as % of merchandise exports) in Cuba in 2002 to that in 2003?
Ensure brevity in your answer.  0.96. What is the ratio of the Imports(as % of merchandise exports) of Czech Republic in 2002 to that in 2003?
Your answer should be very brief. 1.83. What is the ratio of the Imports(as % of merchandise exports) of Hong Kong in 2002 to that in 2003?
Your answer should be very brief. 0.99. What is the ratio of the Imports(as % of merchandise exports) of Macao in 2002 to that in 2003?
Provide a succinct answer. 1.01. What is the ratio of the Imports(as % of merchandise exports) of Cuba in 2002 to that in 2004?
Your response must be concise. 0.89. What is the ratio of the Imports(as % of merchandise exports) in Czech Republic in 2002 to that in 2004?
Keep it short and to the point. 2.08. What is the ratio of the Imports(as % of merchandise exports) in Hong Kong in 2002 to that in 2004?
Offer a terse response. 0.84. What is the ratio of the Imports(as % of merchandise exports) of Macao in 2002 to that in 2004?
Offer a terse response. 0.94. What is the ratio of the Imports(as % of merchandise exports) in Cuba in 2002 to that in 2005?
Ensure brevity in your answer.  0.8. What is the ratio of the Imports(as % of merchandise exports) in Czech Republic in 2002 to that in 2005?
Offer a terse response. 2.08. What is the ratio of the Imports(as % of merchandise exports) in Hong Kong in 2002 to that in 2005?
Offer a terse response. 0.75. What is the ratio of the Imports(as % of merchandise exports) of Macao in 2002 to that in 2005?
Ensure brevity in your answer.  0.75. What is the ratio of the Imports(as % of merchandise exports) in Cuba in 2003 to that in 2004?
Offer a terse response. 0.92. What is the ratio of the Imports(as % of merchandise exports) of Czech Republic in 2003 to that in 2004?
Provide a short and direct response. 1.13. What is the ratio of the Imports(as % of merchandise exports) in Hong Kong in 2003 to that in 2004?
Offer a terse response. 0.85. What is the ratio of the Imports(as % of merchandise exports) in Macao in 2003 to that in 2004?
Offer a very short reply. 0.93. What is the ratio of the Imports(as % of merchandise exports) of Cuba in 2003 to that in 2005?
Offer a terse response. 0.83. What is the ratio of the Imports(as % of merchandise exports) of Czech Republic in 2003 to that in 2005?
Give a very brief answer. 1.14. What is the ratio of the Imports(as % of merchandise exports) of Hong Kong in 2003 to that in 2005?
Offer a terse response. 0.76. What is the ratio of the Imports(as % of merchandise exports) of Macao in 2003 to that in 2005?
Provide a succinct answer. 0.74. What is the ratio of the Imports(as % of merchandise exports) of Cuba in 2004 to that in 2005?
Offer a very short reply. 0.9. What is the ratio of the Imports(as % of merchandise exports) in Czech Republic in 2004 to that in 2005?
Offer a very short reply. 1. What is the ratio of the Imports(as % of merchandise exports) in Hong Kong in 2004 to that in 2005?
Keep it short and to the point. 0.89. What is the ratio of the Imports(as % of merchandise exports) of Macao in 2004 to that in 2005?
Your answer should be compact. 0.8. What is the difference between the highest and the second highest Imports(as % of merchandise exports) in Cuba?
Give a very brief answer. 2.11. What is the difference between the highest and the second highest Imports(as % of merchandise exports) of Czech Republic?
Your answer should be very brief. 3.96. What is the difference between the highest and the second highest Imports(as % of merchandise exports) of Hong Kong?
Make the answer very short. 0.29. What is the difference between the highest and the second highest Imports(as % of merchandise exports) of Macao?
Your response must be concise. 1.79. What is the difference between the highest and the lowest Imports(as % of merchandise exports) of Cuba?
Give a very brief answer. 9.36. What is the difference between the highest and the lowest Imports(as % of merchandise exports) in Czech Republic?
Offer a terse response. 7.05. What is the difference between the highest and the lowest Imports(as % of merchandise exports) in Hong Kong?
Provide a succinct answer. 0.67. What is the difference between the highest and the lowest Imports(as % of merchandise exports) in Macao?
Your answer should be compact. 3.31. 